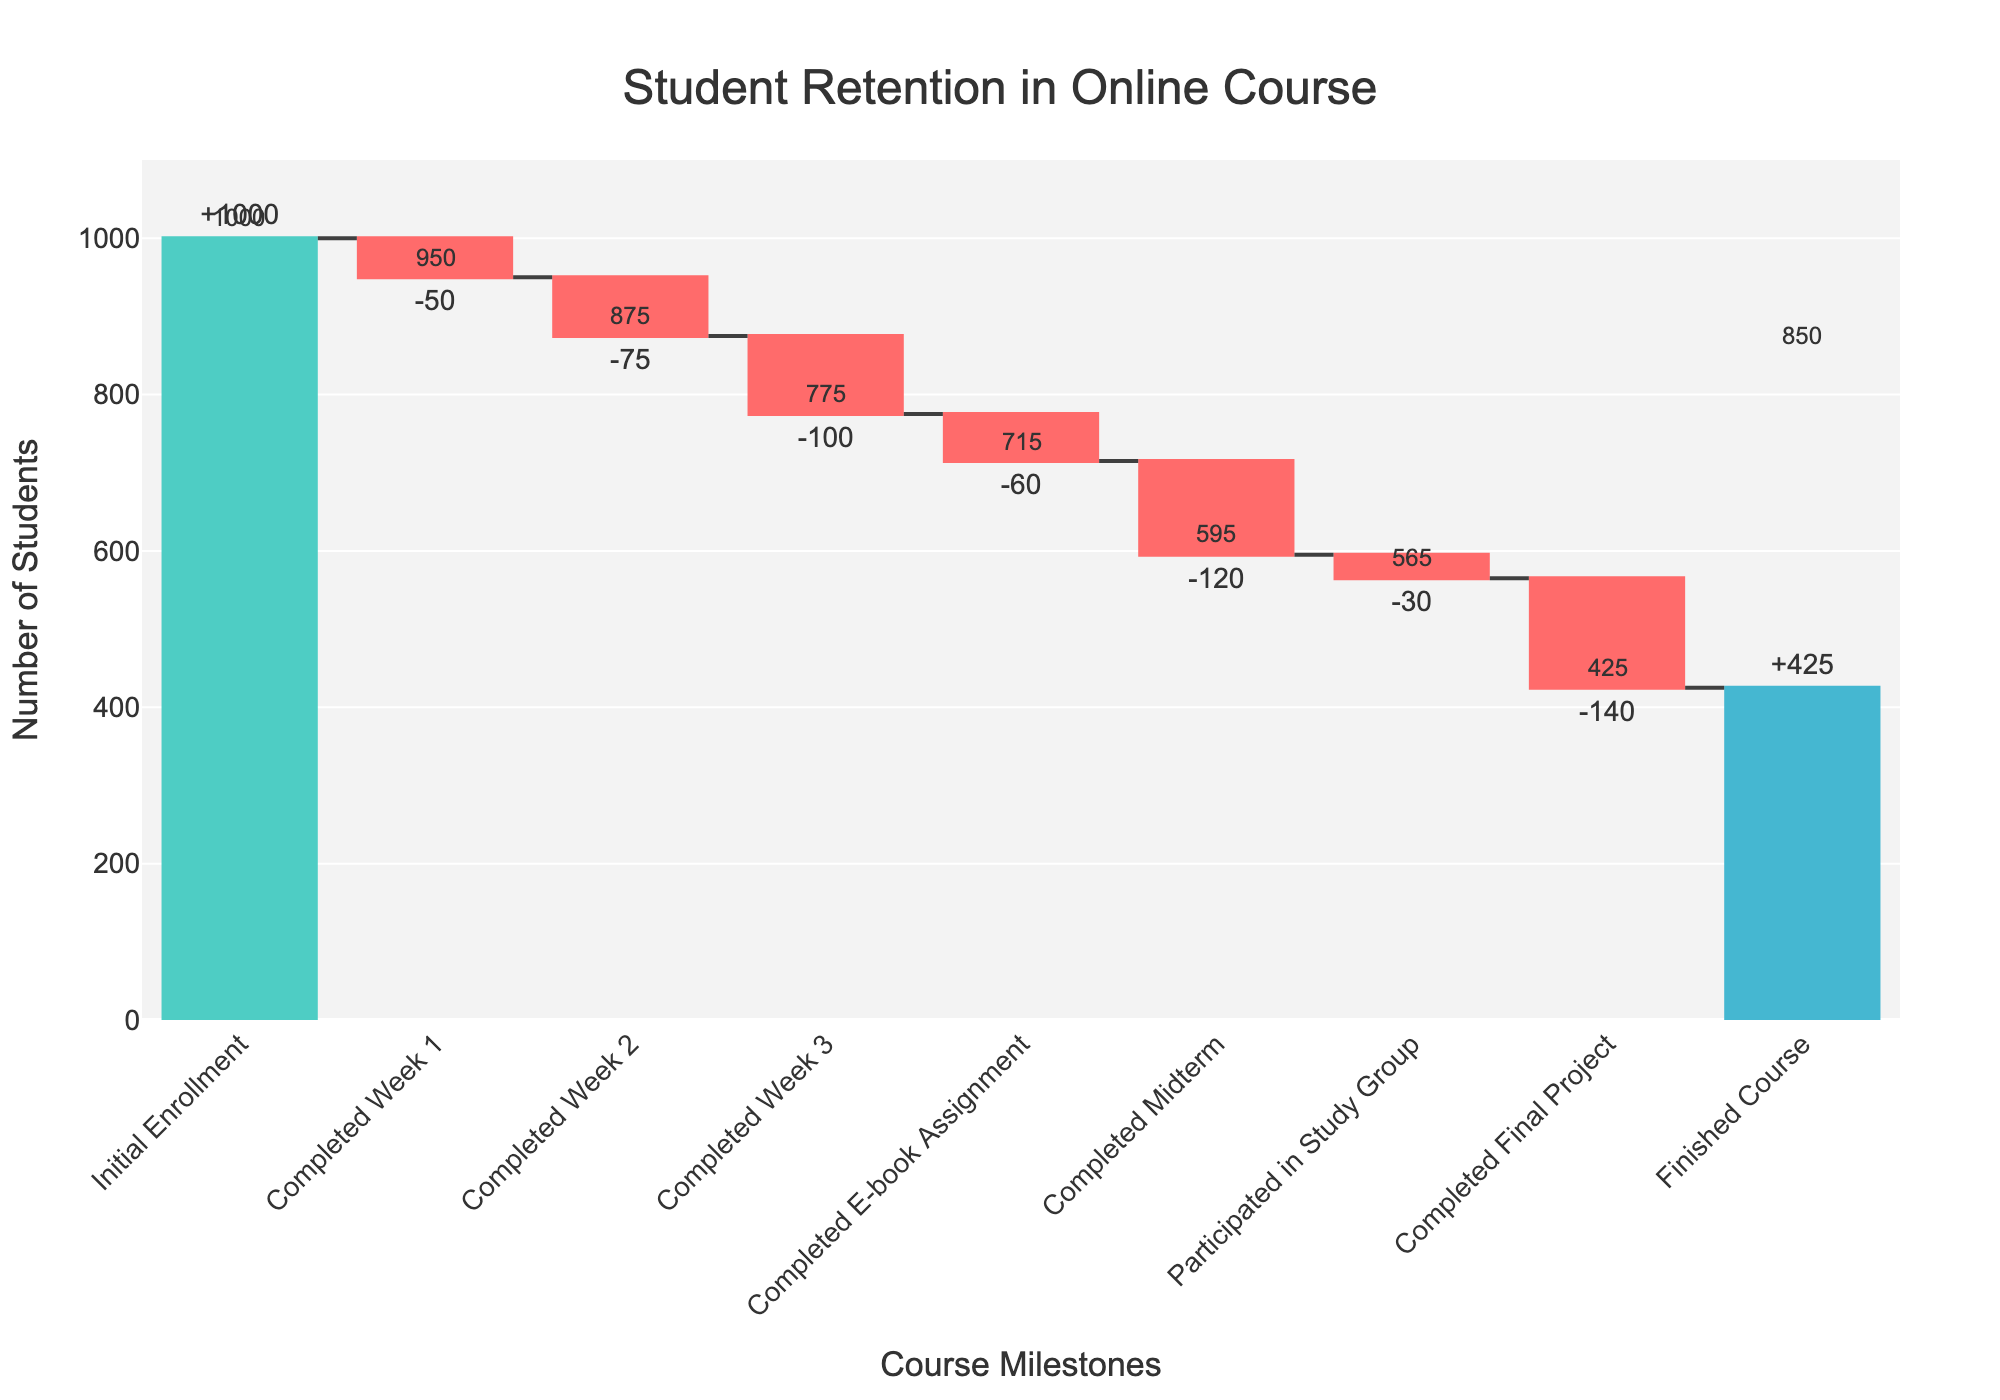What's the title of the chart? The title is located at the top of the chart, typically centered, and is intended to give a quick understanding of the main topic the chart is portraying.
Answer: Student Retention in Online Course How many students completed the Final Project? Look at the step labeled "Completed Final Project" and read the corresponding value.
Answer: 140 What is the total number of students who completed the course? Look at the final step labeled "Finished Course" and read the value associated with it.
Answer: 425 What is the total decrease in the number of students from Initial Enrollment to Completed Week 3? To find the total decrease, sum the values from "Completed Week 1," "Completed Week 2," and "Completed Week 3": -50 + -75 + -100 = -225.
Answer: 225 At which course milestone was the highest number of students retained compared to the previous step? Compare the absolute values of changes at each step. The smallest negative change in the "Completed E-book Assignment," "Completed Midterm," "Participated in Study Group," and "Completed Final Project" indicates the highest retention: -30 at "Participated in Study Group."
Answer: Participated in Study Group How many more students were lost at the Midterm compared to the E-book Assignment? Subtract the number of students lost at the E-book Assignment from those lost at the Midterm: -120 - (-60) = -60.
Answer: 60 Which step had the least drop-off of students? Identify the step with the smallest absolute change value: "Participated in Study Group," which has a change of -30.
Answer: Participated in Study Group By how much did the number of students decrease from the Initial Enrollment to the Finished Course count? Subtract the final count from the initial count: 1000 - 425 = 575.
Answer: 575 What's the cumulative number of students after the Midterm? Sum the changes from Initial Enrollment through Midterm: 1000 - 50 - 75 - 100 - 60 - 120 = 595.
Answer: 595 